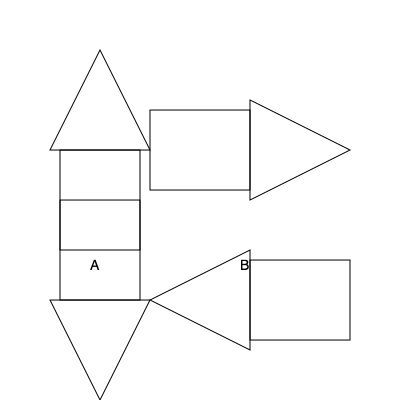The image above shows a simplified representation of the local government building in Kalach. If this building is rotated 180 degrees, which of the options (B, C, or D) correctly represents its new orientation? To solve this problem, we need to understand how a 180-degree rotation affects the orientation of an object:

1. A 180-degree rotation is equivalent to flipping the object upside down.
2. In this rotation, the top becomes the bottom, and the left side becomes the right side.

Let's analyze each option:

A. This is the original orientation of the building.
B. This shows a 90-degree clockwise rotation, which is not what we're looking for.
C. This shows a 180-degree rotation:
   - The triangular roof is now at the bottom.
   - The rectangular base is now at the top.
   - The entire structure is flipped vertically.
D. This shows a 90-degree counterclockwise rotation, which is not correct.

Therefore, option C correctly represents the building after a 180-degree rotation.
Answer: C 